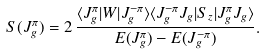<formula> <loc_0><loc_0><loc_500><loc_500>S ( J _ { g } ^ { \pi } ) = 2 \, \frac { \langle J _ { g } ^ { \pi } | W | J _ { g } ^ { - \pi } \rangle \langle J _ { g } ^ { - \pi } J _ { g } | S _ { z } | J _ { g } ^ { \pi } J _ { g } \rangle } { E ( J _ { g } ^ { \pi } ) - E ( J _ { g } ^ { - \pi } ) } .</formula> 